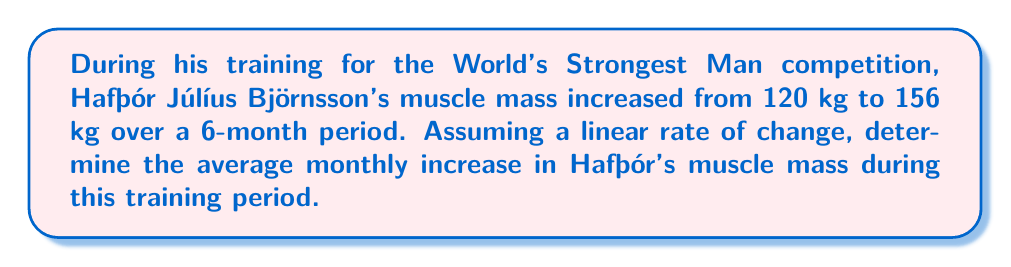Help me with this question. To solve this problem, we need to follow these steps:

1. Identify the given information:
   - Initial muscle mass: 120 kg
   - Final muscle mass: 156 kg
   - Time period: 6 months

2. Calculate the total change in muscle mass:
   $\Delta \text{mass} = \text{Final mass} - \text{Initial mass}$
   $\Delta \text{mass} = 156 \text{ kg} - 120 \text{ kg} = 36 \text{ kg}$

3. Calculate the rate of change using the formula:
   $$\text{Rate of change} = \frac{\text{Change in quantity}}{\text{Change in time}}$$

   In this case:
   $$\text{Rate of change} = \frac{\Delta \text{mass}}{\Delta \text{time}} = \frac{36 \text{ kg}}{6 \text{ months}}$$

4. Simplify the fraction:
   $$\text{Rate of change} = \frac{36 \text{ kg}}{6 \text{ months}} = 6 \text{ kg/month}$$

Therefore, Hafþór's muscle mass increased at an average rate of 6 kg per month during his training period.
Answer: $6 \text{ kg/month}$ 